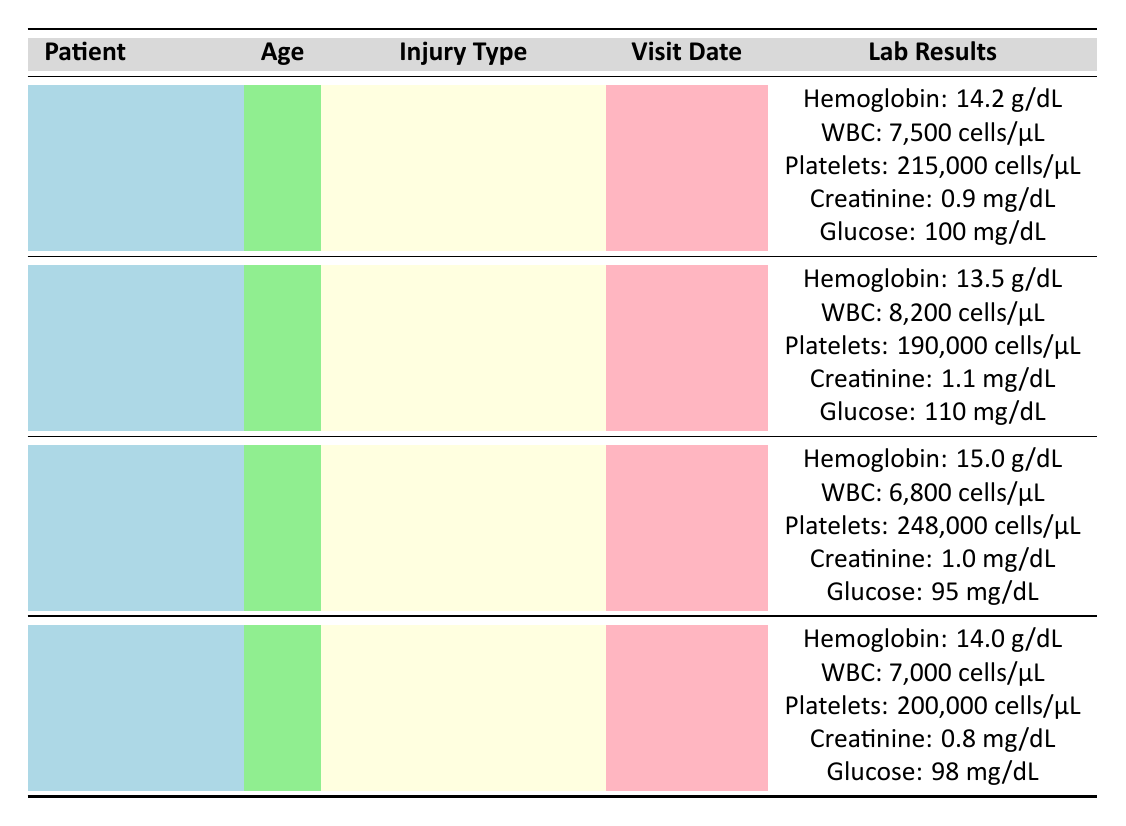What is John Doe's hemoglobin level? John Doe's row lists his hemoglobin level as 14.2 g/dL under lab results.
Answer: 14.2 g/dL How many patients had a white blood cell count greater than 8,000 cells/µL? Alice Smith's white blood cell count is 8,200 cells/µL, which is greater than 8,000 cells/µL. John Doe and Robert Johnson had counts less than this threshold. Thus, only Alice fits this condition.
Answer: 1 What is the average platelet count of all patients? To find the average platelet count, add the platelet counts: 215,000 + 190,000 + 248,000 + 200,000 = 853,000. Divide by the number of patients (4): 853,000 / 4 = 213,250.
Answer: 213,250 cells/µL Is Margaret Brown's creatinine level lower than John Doe's? Margaret Brown's creatinine level is 0.8 mg/dL, while John Doe's is 0.9 mg/dL. Since 0.8 is less than 0.9, the statement is true.
Answer: Yes What is the difference in hemoglobin levels between Robert Johnson and Alice Smith? Robert Johnson's hemoglobin level is 15.0 g/dL and Alice Smith's is 13.5 g/dL. The difference is 15.0 - 13.5 = 1.5 g/dL.
Answer: 1.5 g/dL How many patients were tested for hook puncture wounds? Only John Doe had a hook puncture wound according to the injury type listed in the table.
Answer: 1 Did any patient have a blood glucose level lower than 100 mg/dL? John Doe and Robert Johnson both have levels equal to or above 100 mg/dL, while Alice Smith had 110 mg/dL and Margaret Brown had 98 mg/dL. Thus, Margaret Brown is the only one below 100 mg/dL.
Answer: Yes What is the total number of cells in white blood cells for all patients? Adding the white blood cell counts gives: 7,500 + 8,200 + 6,800 + 7,000 = 29,500 cells/µL.
Answer: 29,500 cells/µL Which patient had the highest blood glucose level? Among the blood glucose levels, Alice Smith has the highest at 110 mg/dL. The others are lower: John Doe at 100, Robert Johnson at 95, and Margaret Brown at 98.
Answer: Alice Smith 